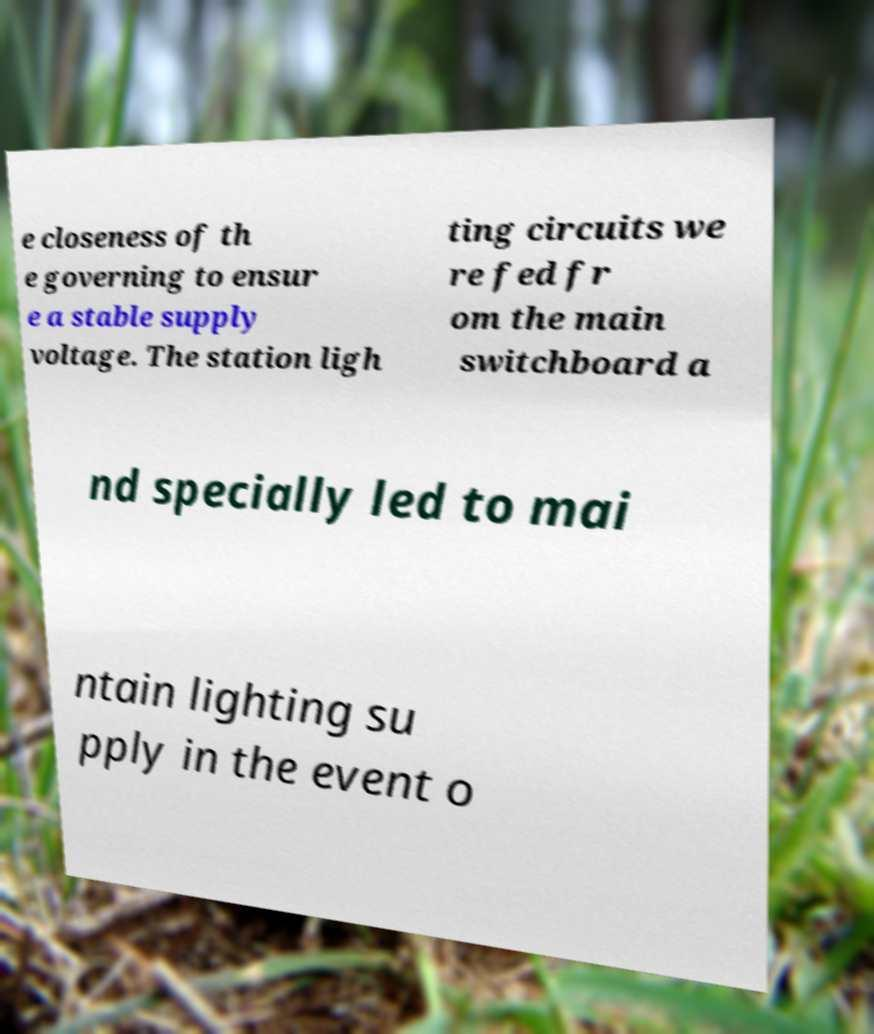Could you assist in decoding the text presented in this image and type it out clearly? e closeness of th e governing to ensur e a stable supply voltage. The station ligh ting circuits we re fed fr om the main switchboard a nd specially led to mai ntain lighting su pply in the event o 